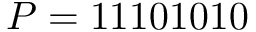<formula> <loc_0><loc_0><loc_500><loc_500>P = 1 1 1 0 1 0 1 0</formula> 